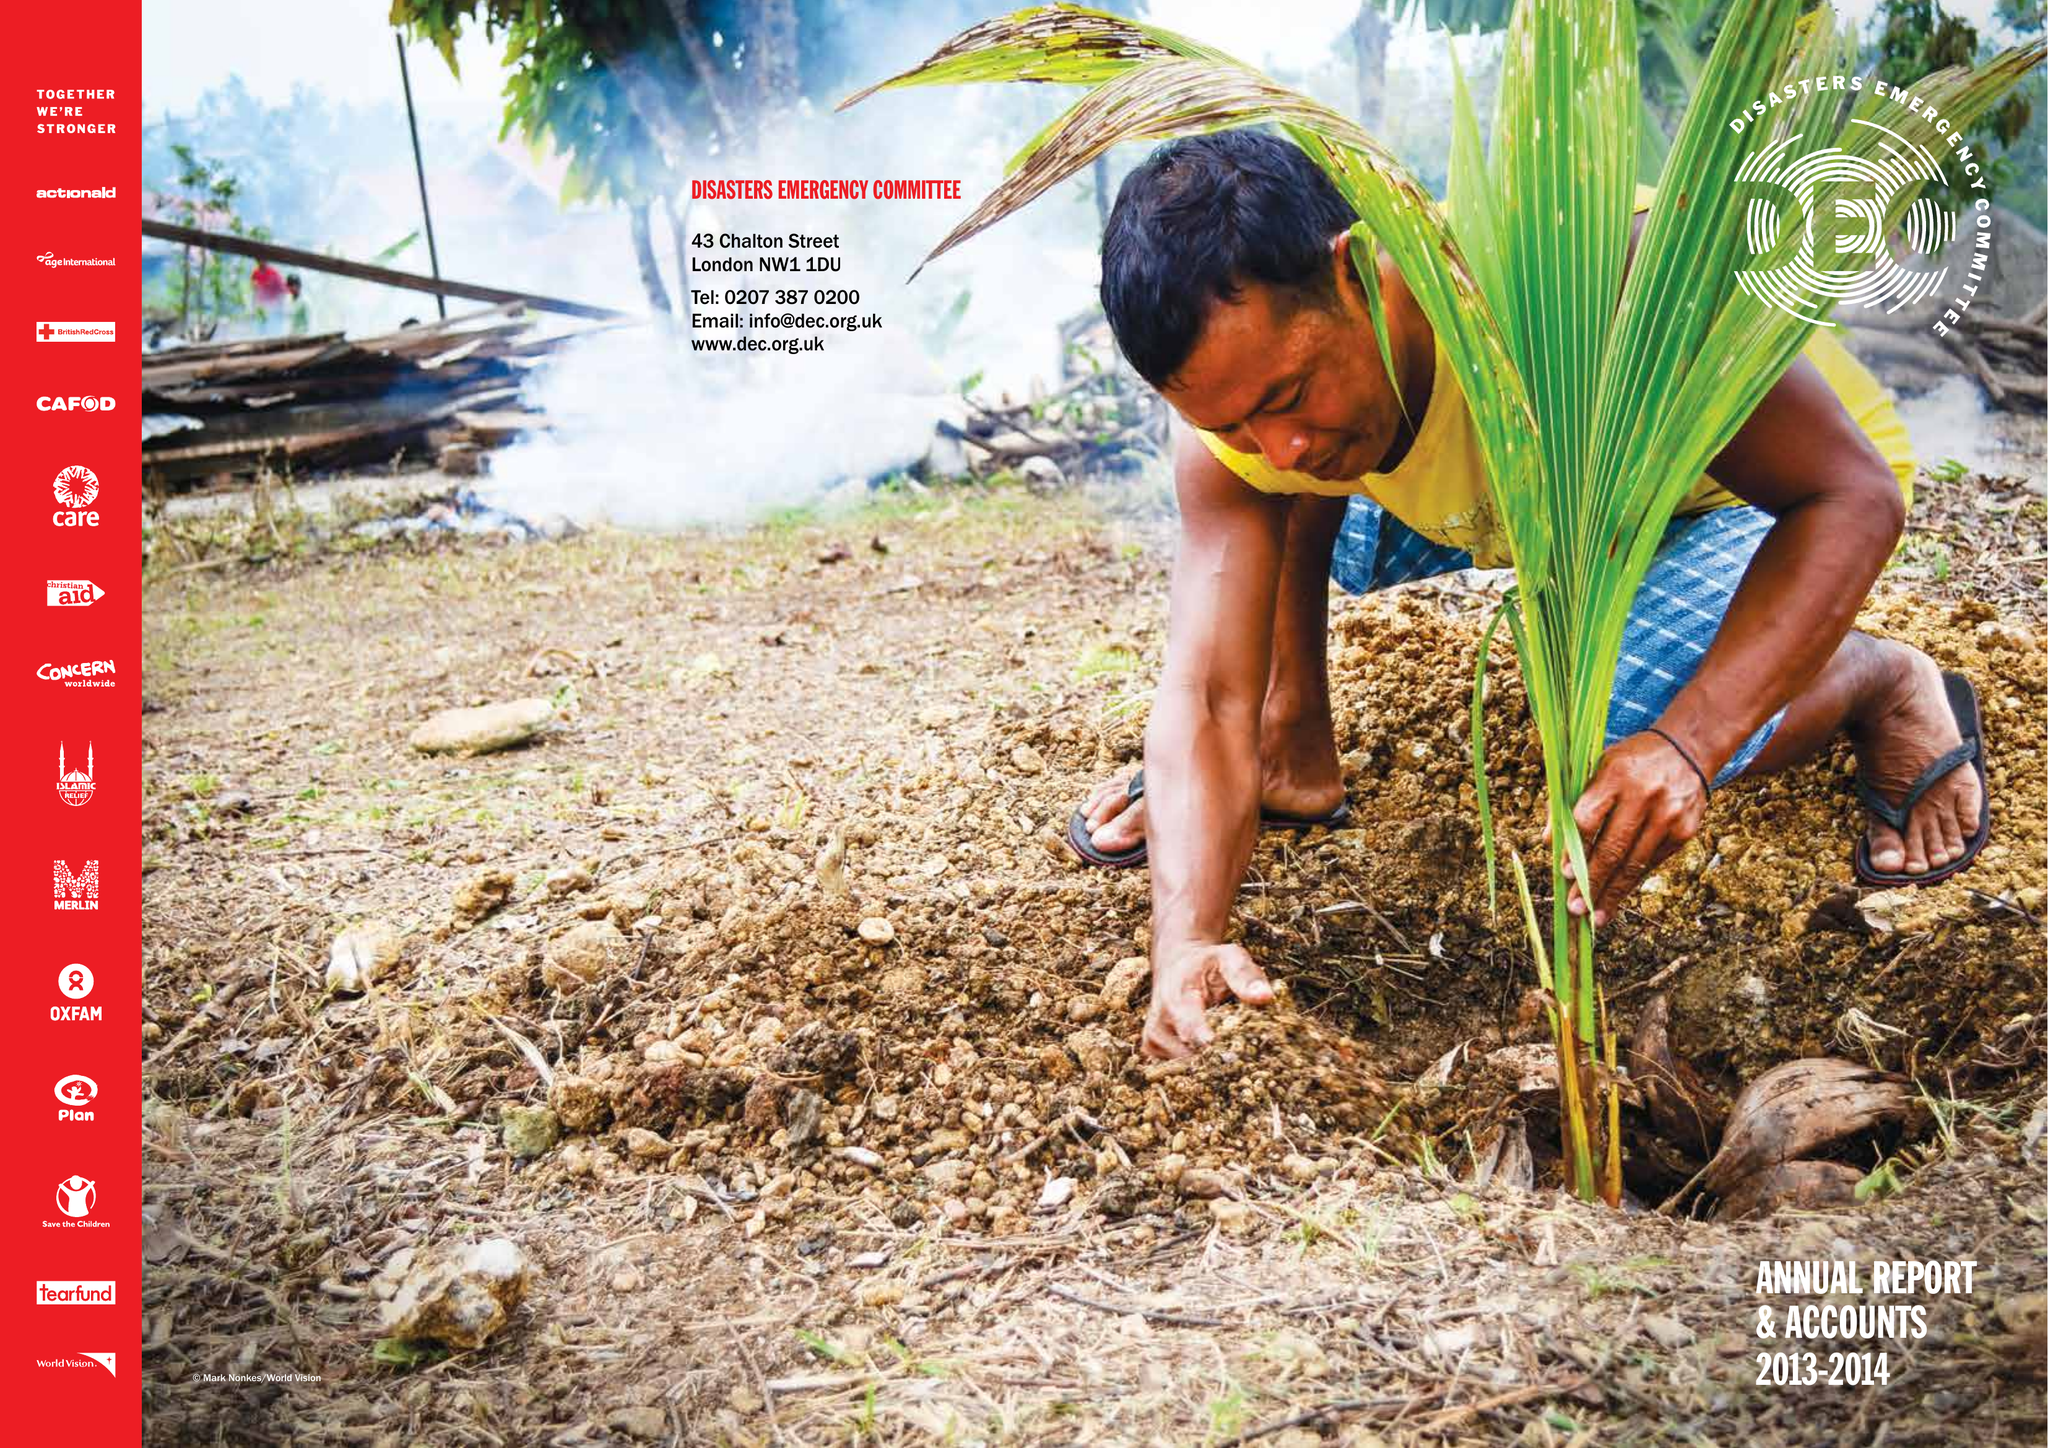What is the value for the spending_annually_in_british_pounds?
Answer the question using a single word or phrase. 29125000.00 